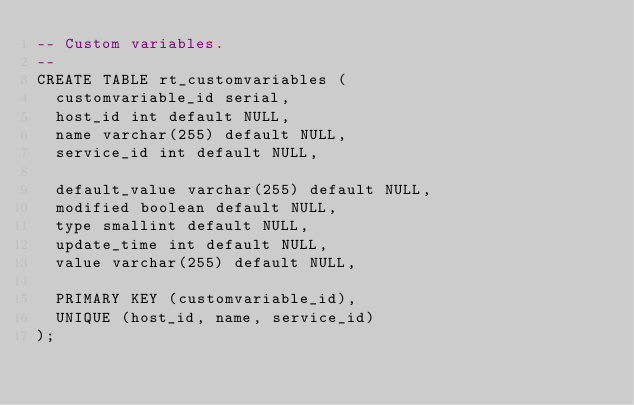Convert code to text. <code><loc_0><loc_0><loc_500><loc_500><_SQL_>-- Custom variables.
--
CREATE TABLE rt_customvariables (
  customvariable_id serial,
  host_id int default NULL,
  name varchar(255) default NULL,
  service_id int default NULL,

  default_value varchar(255) default NULL,
  modified boolean default NULL,
  type smallint default NULL,
  update_time int default NULL,
  value varchar(255) default NULL,

  PRIMARY KEY (customvariable_id),
  UNIQUE (host_id, name, service_id)
);
</code> 